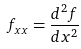<formula> <loc_0><loc_0><loc_500><loc_500>f _ { x x } = \frac { d ^ { 2 } f } { d x ^ { 2 } }</formula> 